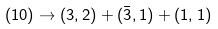<formula> <loc_0><loc_0><loc_500><loc_500>( 1 0 ) \rightarrow ( 3 , 2 ) + ( \bar { 3 } , 1 ) + ( 1 , 1 )</formula> 